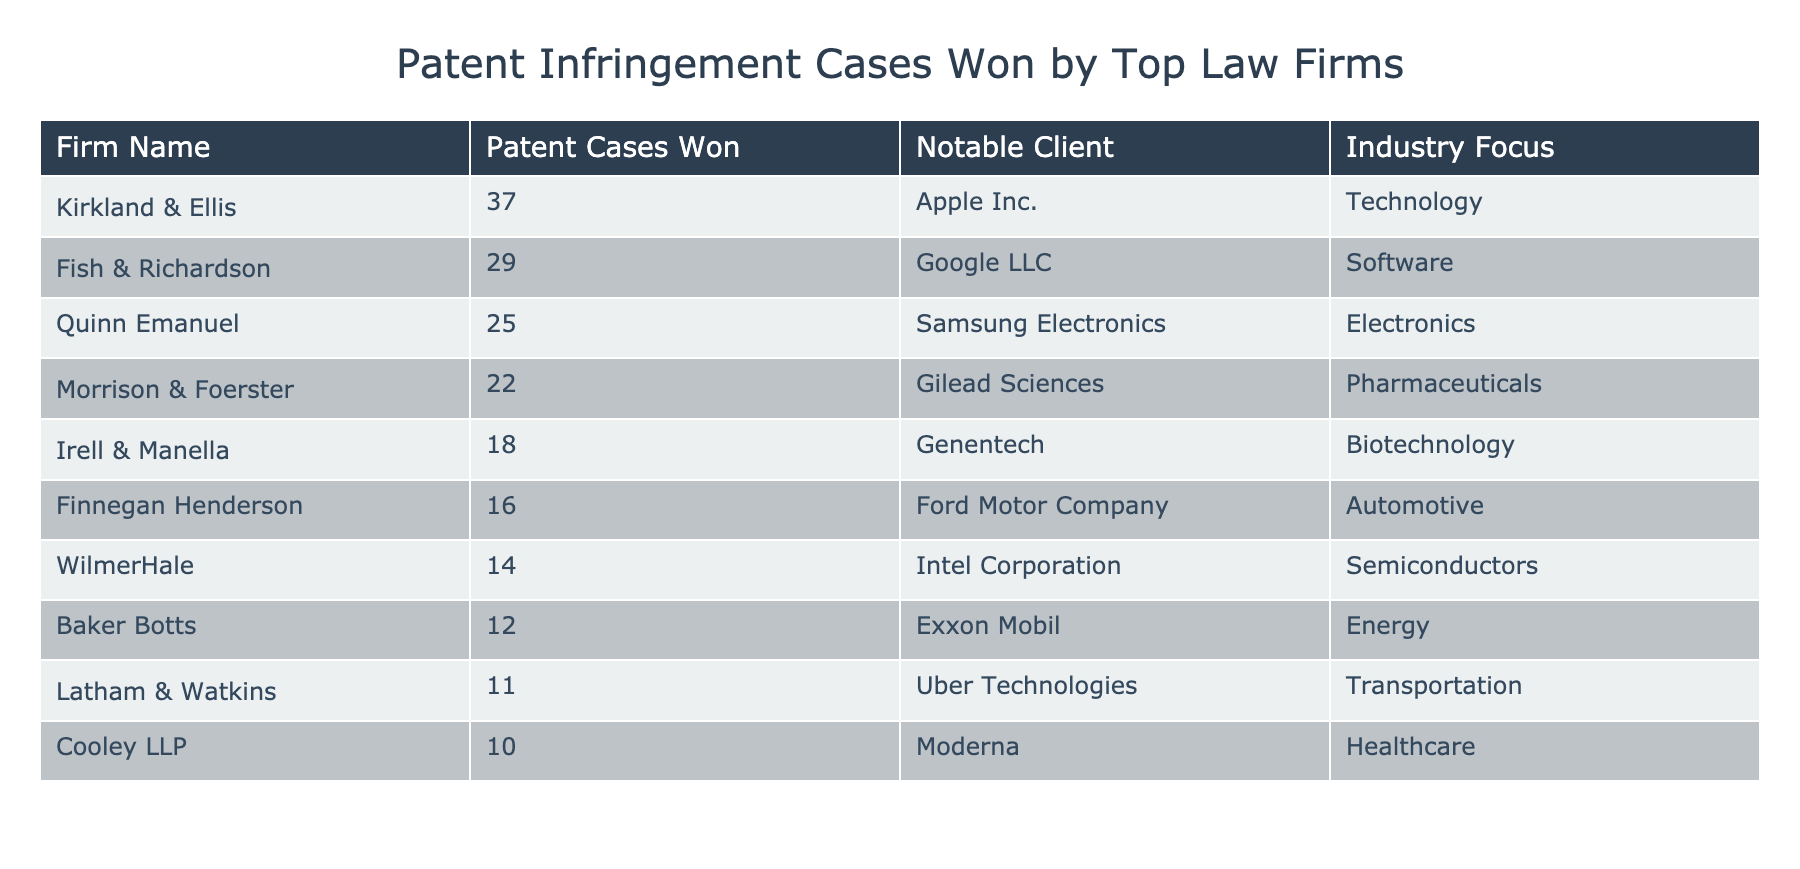What is the highest number of patent cases won by a single firm? The firm with the highest number of patent cases won is Kirkland & Ellis, with a total of 37 cases. I identified this by scanning the "Patent Cases Won" column for the maximum value.
Answer: 37 Which firm represents Apple Inc. in patent infringement cases? The firm representing Apple Inc. is Kirkland & Ellis, as noted in the "Notable Client" column corresponding to "Firm Name."
Answer: Kirkland & Ellis What is the total number of patent infringement cases won by the top three firms? To find this, I sum the "Patent Cases Won" for the top three firms: Kirkland & Ellis (37) + Fish & Richardson (29) + Quinn Emanuel (25) = 91 cases in total.
Answer: 91 Does Baker Botts represent a client in the energy sector? Yes, Baker Botts represents Exxon Mobil, which operates in the energy sector, as indicated in the "Notable Client" and "Industry Focus" columns.
Answer: Yes What is the average number of patent cases won by all firms listed? To calculate the average, I sum all the patent cases won (37 + 29 + 25 + 22 + 18 + 16 + 14 + 12 + 11 + 10 =  274), then divide by the number of firms (10): 274/10 = 27.4.
Answer: 27.4 Which industry has the highest representation among notable clients in this table? The technology and software industries have the highest representation because Kirkland & Ellis (Technology) and Fish & Richardson (Software) are both notable, but there may be more cases combined across these two. Since technology has one more representative than pharmaceuticals and others, tech holds the highest presence.
Answer: Technology Is there a firm that won exactly 20 patent cases? No, none of the firms won exactly 20 patent cases; the closest values are 22 (Morrison & Foerster) and 18 (Irell & Manella).
Answer: No If the top law firm lost 5 cases in the following year, how many cases would they have won then? If Kirkland & Ellis, the top law firm, lost 5 cases from their current total of 37, they would then have 37 - 5 = 32 cases won in the following year.
Answer: 32 